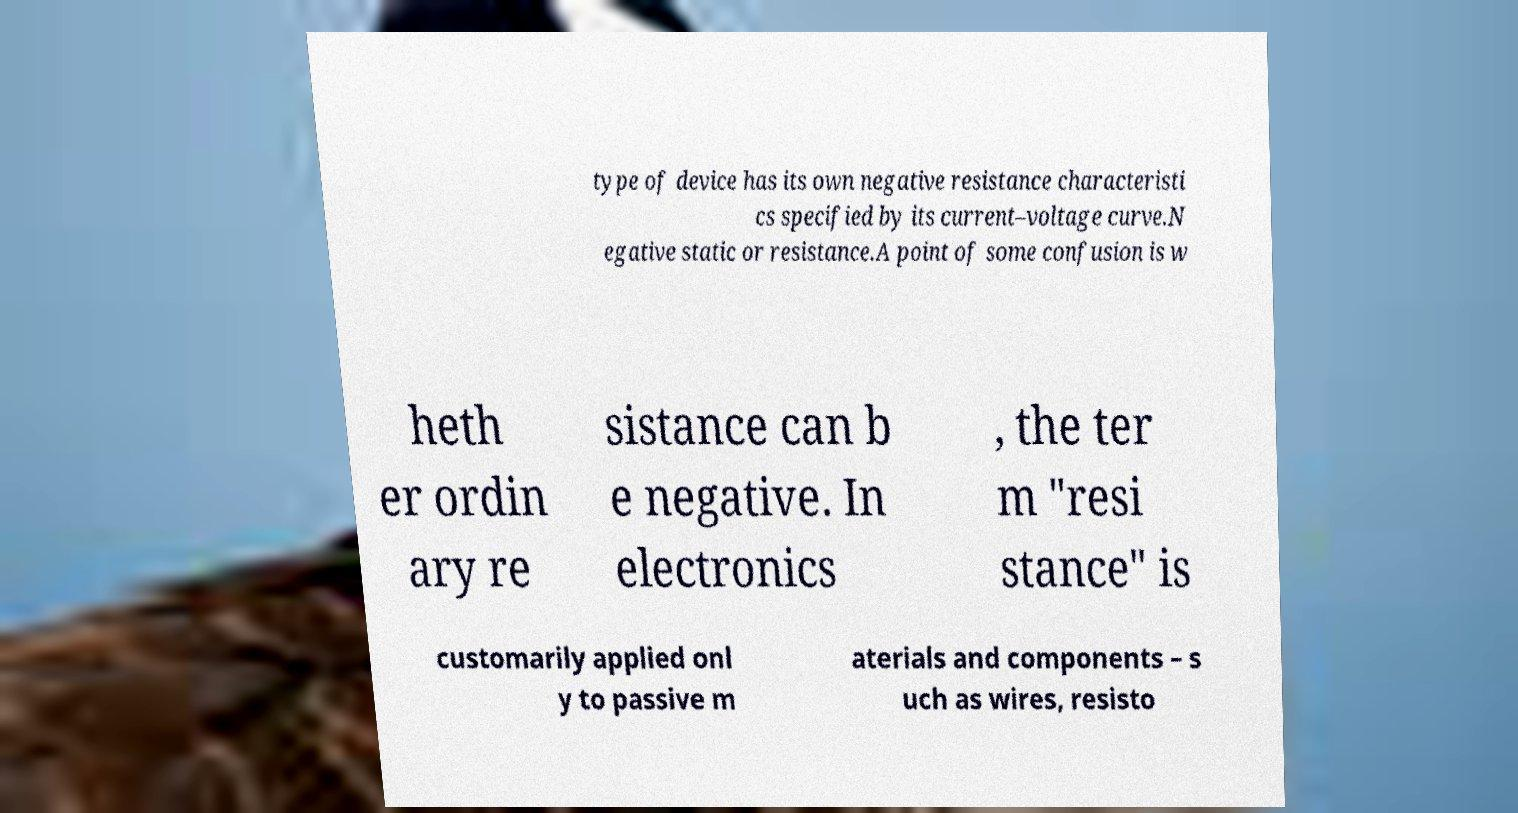For documentation purposes, I need the text within this image transcribed. Could you provide that? type of device has its own negative resistance characteristi cs specified by its current–voltage curve.N egative static or resistance.A point of some confusion is w heth er ordin ary re sistance can b e negative. In electronics , the ter m "resi stance" is customarily applied onl y to passive m aterials and components – s uch as wires, resisto 